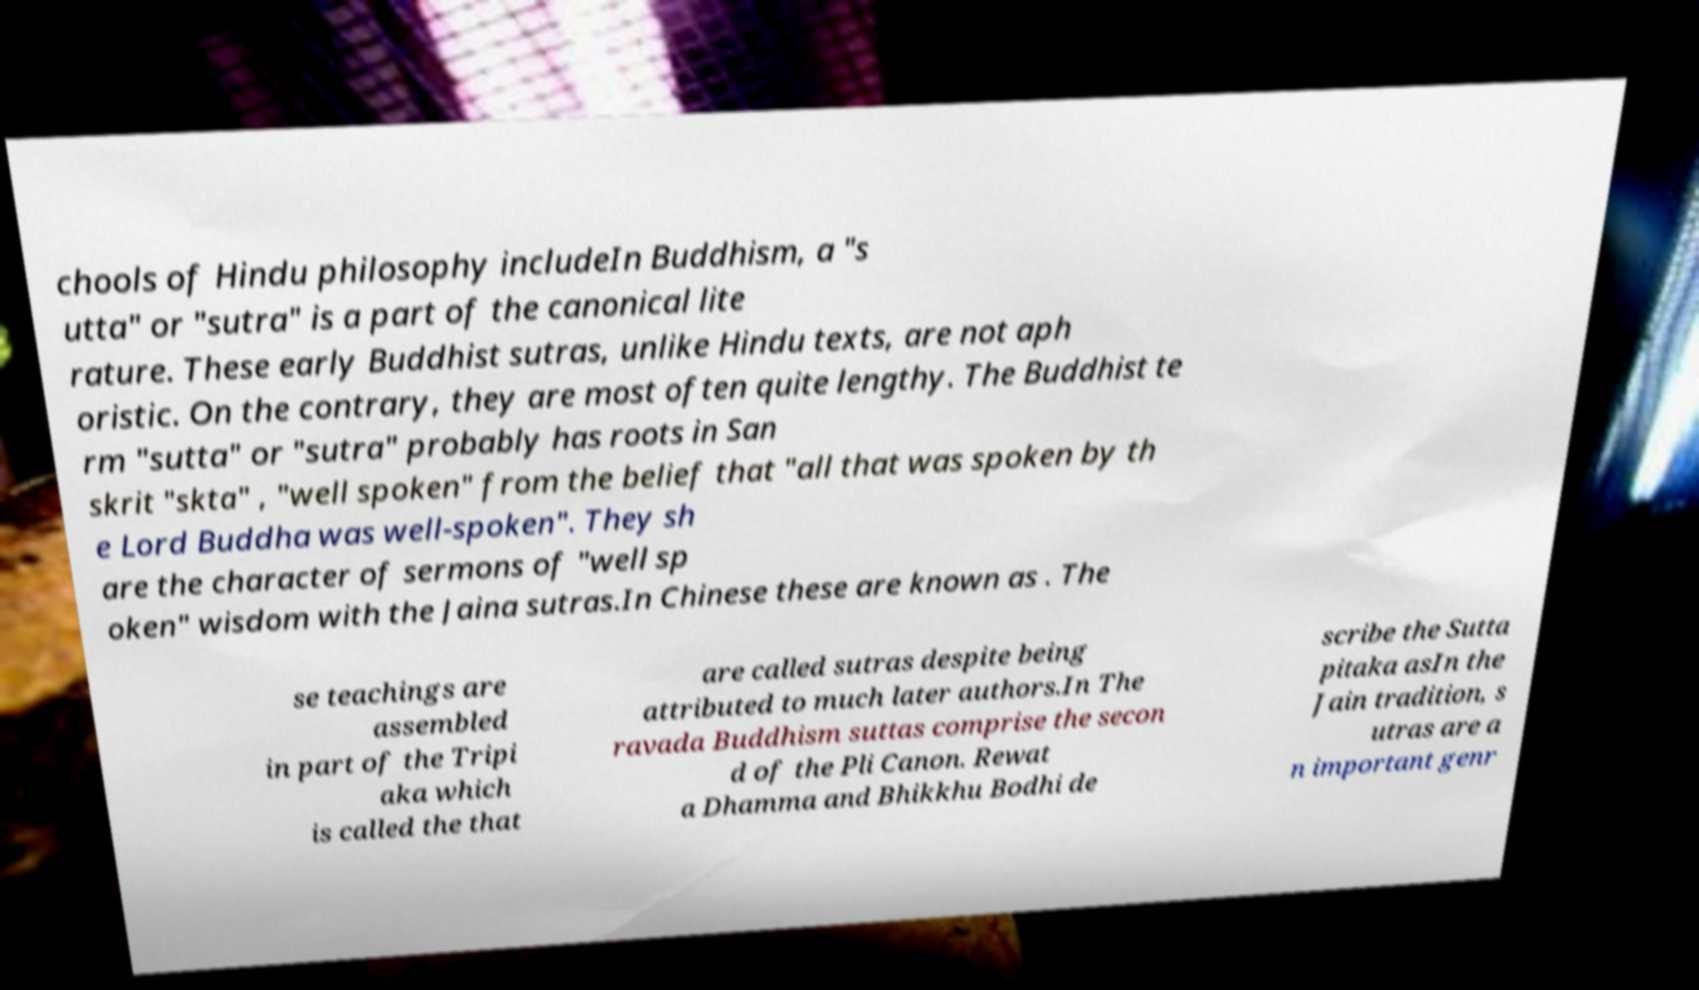Could you extract and type out the text from this image? chools of Hindu philosophy includeIn Buddhism, a "s utta" or "sutra" is a part of the canonical lite rature. These early Buddhist sutras, unlike Hindu texts, are not aph oristic. On the contrary, they are most often quite lengthy. The Buddhist te rm "sutta" or "sutra" probably has roots in San skrit "skta" , "well spoken" from the belief that "all that was spoken by th e Lord Buddha was well-spoken". They sh are the character of sermons of "well sp oken" wisdom with the Jaina sutras.In Chinese these are known as . The se teachings are assembled in part of the Tripi aka which is called the that are called sutras despite being attributed to much later authors.In The ravada Buddhism suttas comprise the secon d of the Pli Canon. Rewat a Dhamma and Bhikkhu Bodhi de scribe the Sutta pitaka asIn the Jain tradition, s utras are a n important genr 